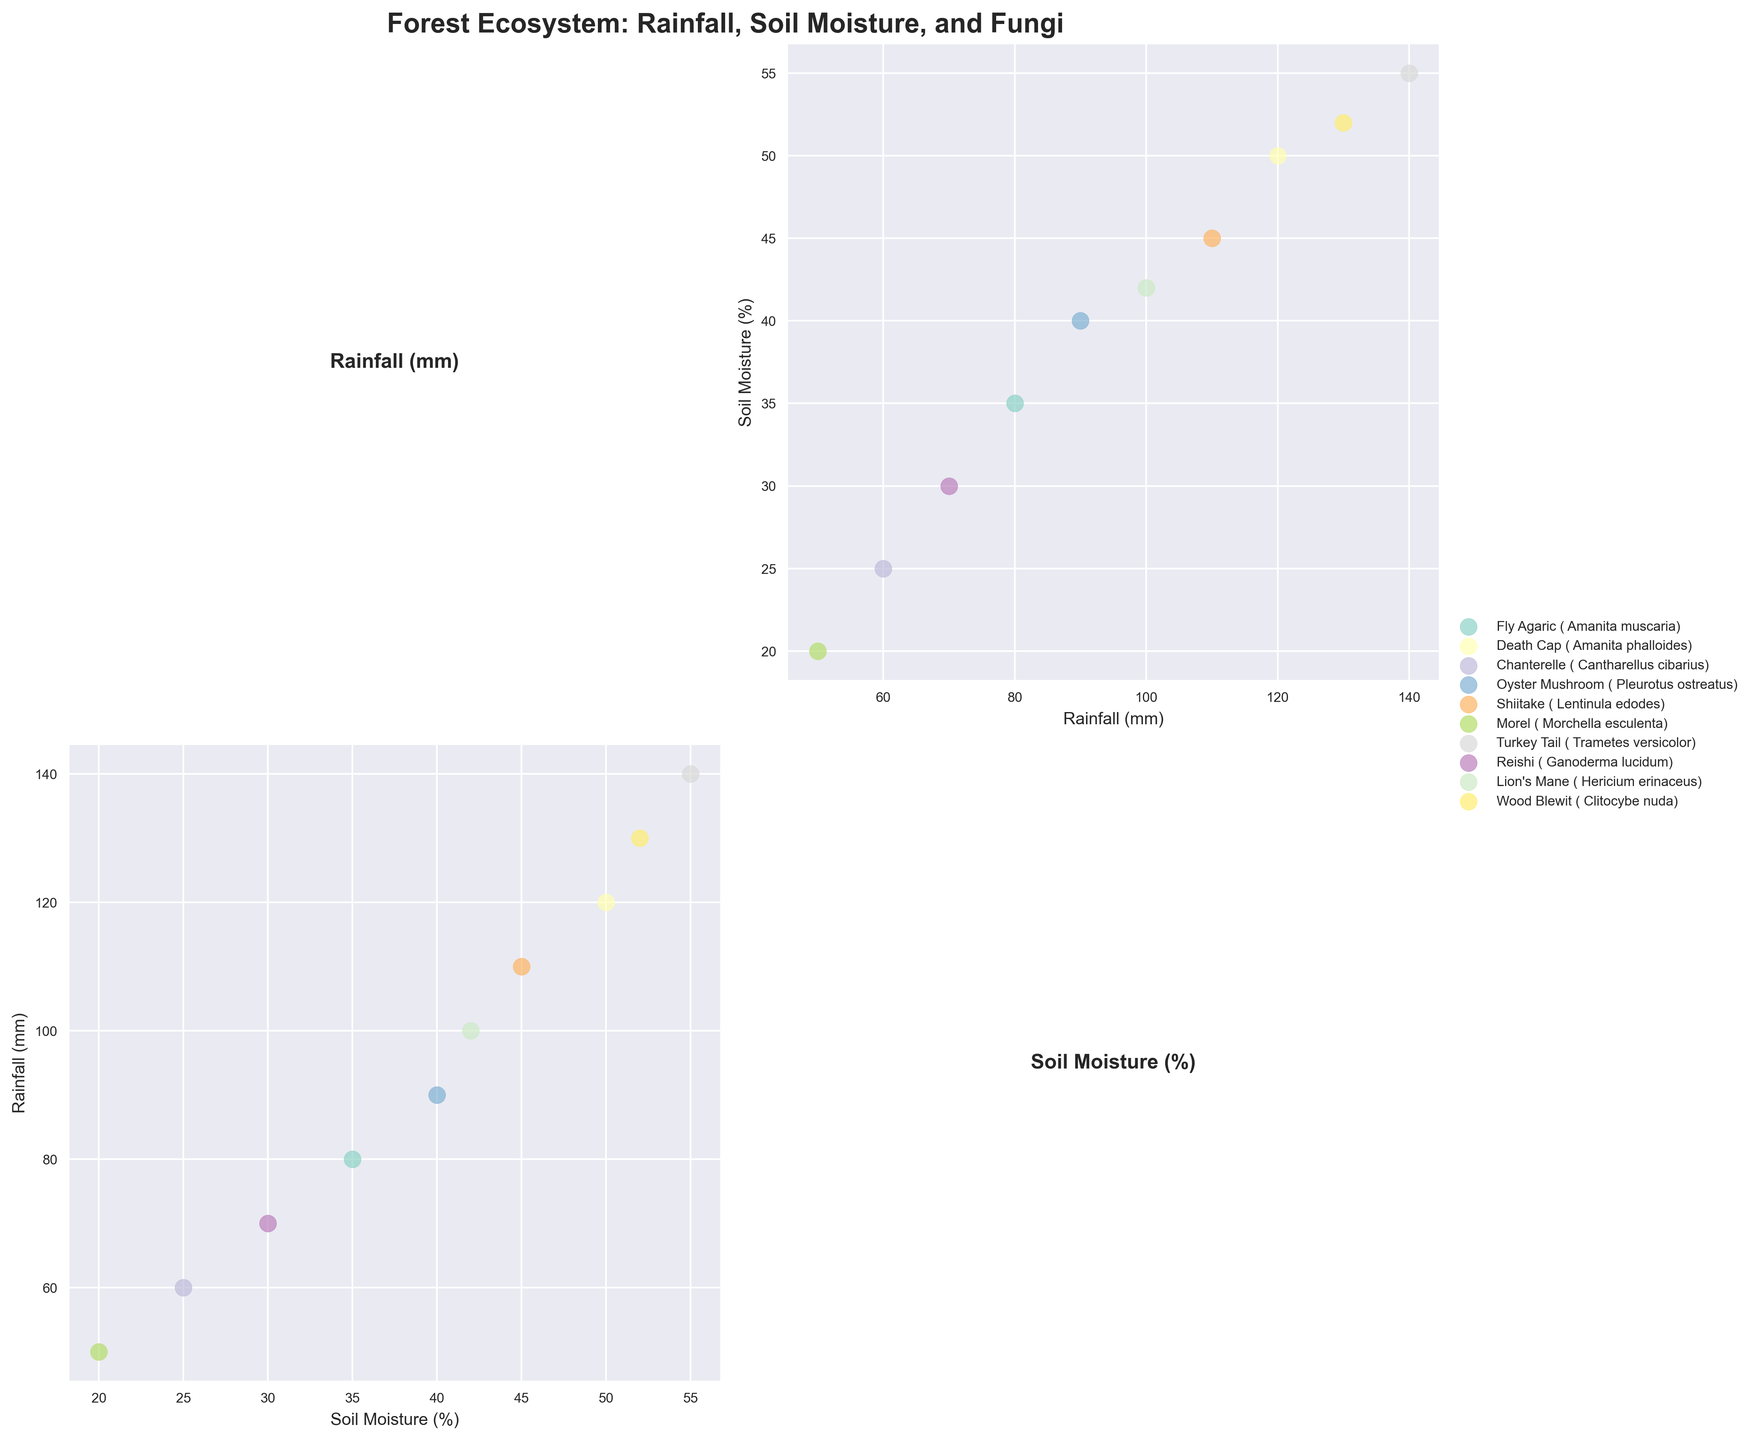Which fungi type is associated with the highest soil moisture percentage? First, locate the soil moisture axis. Then find the highest value and observe which fungi type is associated with it.
Answer: Turkey Tail (Trametes versicolor) What is the title of the scatter plot matrix? Look at the topmost part of the figure where the title is usually placed.
Answer: Forest Ecosystem: Rainfall, Soil Moisture, and Fungi How many data points are plotted in the soil moisture vs. rainfall scatter plot? Count the number of unique data points in the plot located at the intersection of the soil moisture and rainfall axes.
Answer: 10 Which two fungi types have the most similar soil moisture percentages? Compare the soil moisture percentages of each fungi type to find the two that have the closest values.
Answer: Shiitake (Lentinula edodes) and Death Cap (Amanita phalloides) Which fungi appears at the intersection of 50% soil moisture and 120mm rainfall? Locate the data point at the intersection of the 50% soil moisture and 120mm rainfall axes.
Answer: Death Cap (Amanita phalloides) What soil moisture percentage is associated with Lion's Mane? Find the data point labeled 'Lion's Mane' and note its position on the soil moisture axis.
Answer: 42% Among Fly Agaric, Chanterelle, and Oyster Mushroom, which has the highest rainfall? Compare the rainfall values corresponding to Fly Agaric, Chanterelle, and Oyster Mushroom.
Answer: Fly Agaric (Amanita muscaria) Which variable is plotted along the diagonal of the scatter plot matrix? Observe the diagonal plots in the figure to determine which variable they represent.
Answer: The variable itself (Rainfall and Soil Moisture respectively) Is there a fungi type that has a soil moisture percentage below 25%? Check the soil moisture data points to see if any fall below 25% and identify the corresponding fungi type.
Answer: Morel (Morchella esculenta) What is the difference in soil moisture percentage between Wood Blewit and Reishi? Subtract the soil moisture percentage of Reishi from that of Wood Blewit.
Answer: 22 (52% - 30% = 22) 